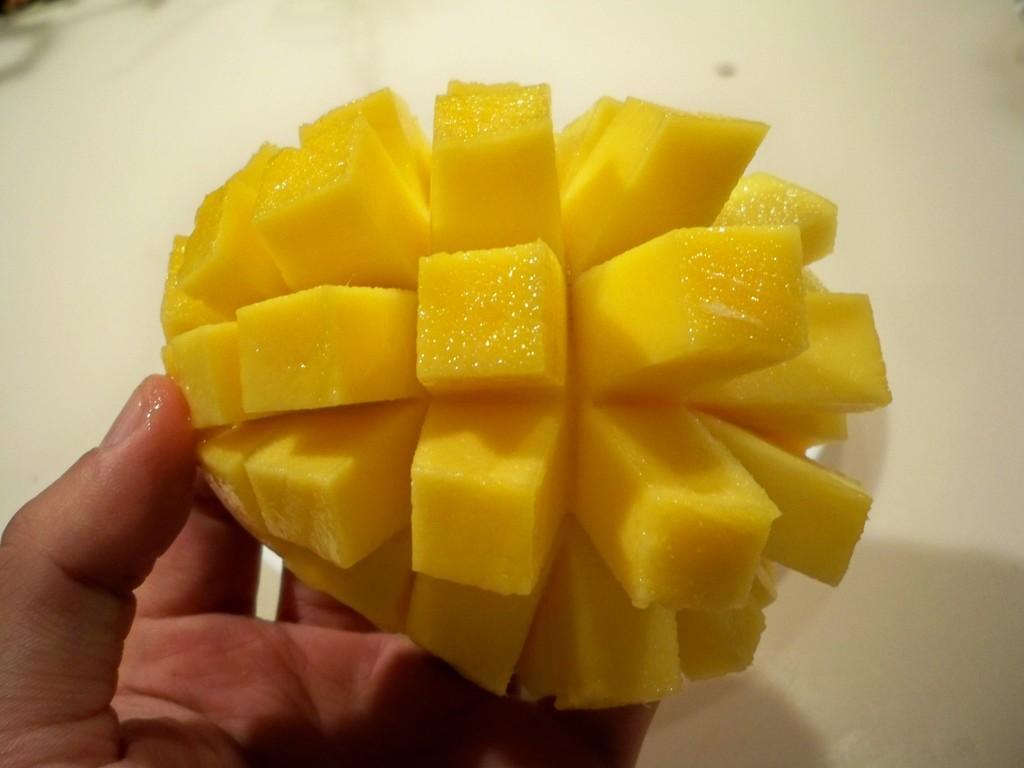Describe this image in one or two sentences. In the image we can see human hand and slices of mango. 